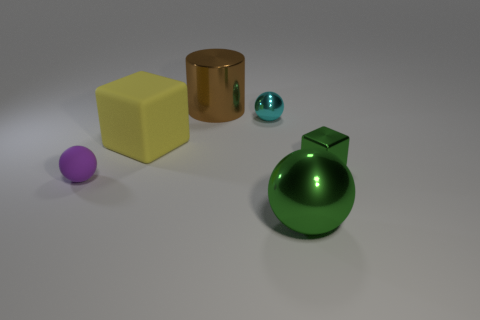Can you describe the way the light is reflected on the surfaces of the objects? Certainly, the light on the objects creates soft highlights and shadows, indicating a diffused lighting environment. The metallic cylinder and the small sphere reflect the light with a distinct glossy sheen, whereas the matte surface of the cube diffuses the light more evenly without strong reflections. 